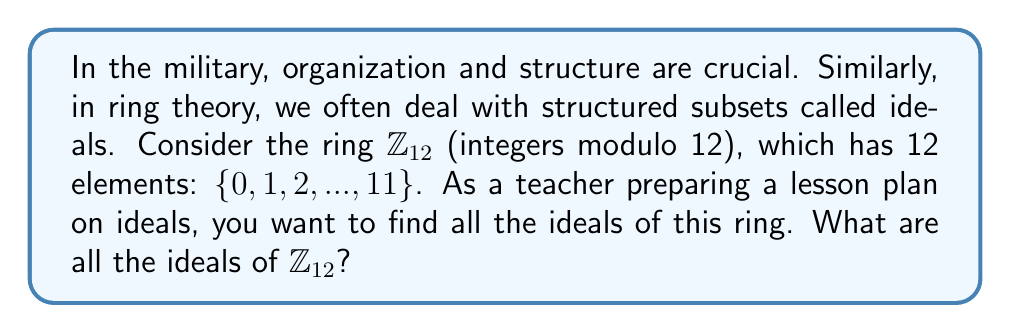Show me your answer to this math problem. To find all ideals of $\mathbb{Z}_{12}$, we'll follow these steps:

1) Recall that in $\mathbb{Z}_n$, the ideals are precisely the subgroups of the additive group of $\mathbb{Z}_n$.

2) The subgroups of $\mathbb{Z}_{12}$ are generated by the divisors of 12. The divisors of 12 are 1, 2, 3, 4, 6, and 12.

3) Let's examine each divisor:

   a) $\langle 1 \rangle = \{0, 1, 2, 3, 4, 5, 6, 7, 8, 9, 10, 11\} = \mathbb{Z}_{12}$
   b) $\langle 2 \rangle = \{0, 2, 4, 6, 8, 10\}$
   c) $\langle 3 \rangle = \{0, 3, 6, 9\}$
   d) $\langle 4 \rangle = \{0, 4, 8\}$
   e) $\langle 6 \rangle = \{0, 6\}$
   f) $\langle 12 \rangle = \{0\}$

4) Each of these subgroups is an ideal in $\mathbb{Z}_{12}$.

5) We can verify that each of these is indeed an ideal:
   - They are all closed under addition in $\mathbb{Z}_{12}$
   - For any element $r$ in $\mathbb{Z}_{12}$ and any element $a$ in the ideal, $ra$ is in the ideal

Therefore, these six subsets are all the ideals of $\mathbb{Z}_{12}$.
Answer: The ideals of $\mathbb{Z}_{12}$ are:

$$\{0\}, \{0, 6\}, \{0, 4, 8\}, \{0, 3, 6, 9\}, \{0, 2, 4, 6, 8, 10\}, \{0, 1, 2, 3, 4, 5, 6, 7, 8, 9, 10, 11\}$$ 